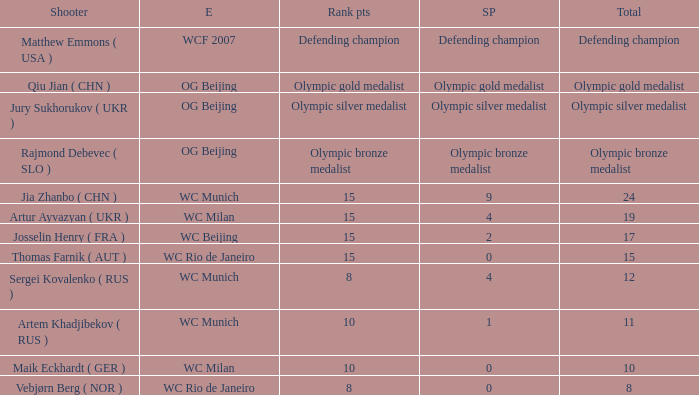With a total of 11, and 10 rank points, what are the score points? 1.0. 